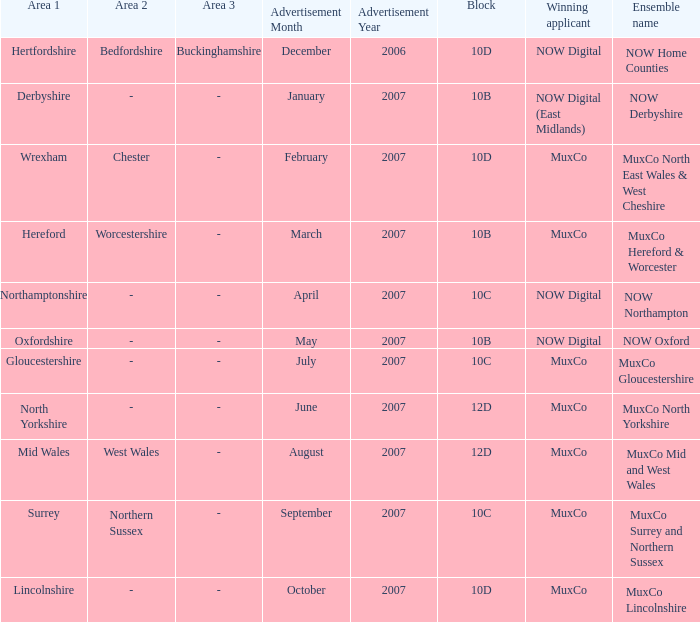Which applicant emerged victorious for block 10b in the area of derbyshire? NOW Digital (East Midlands). 